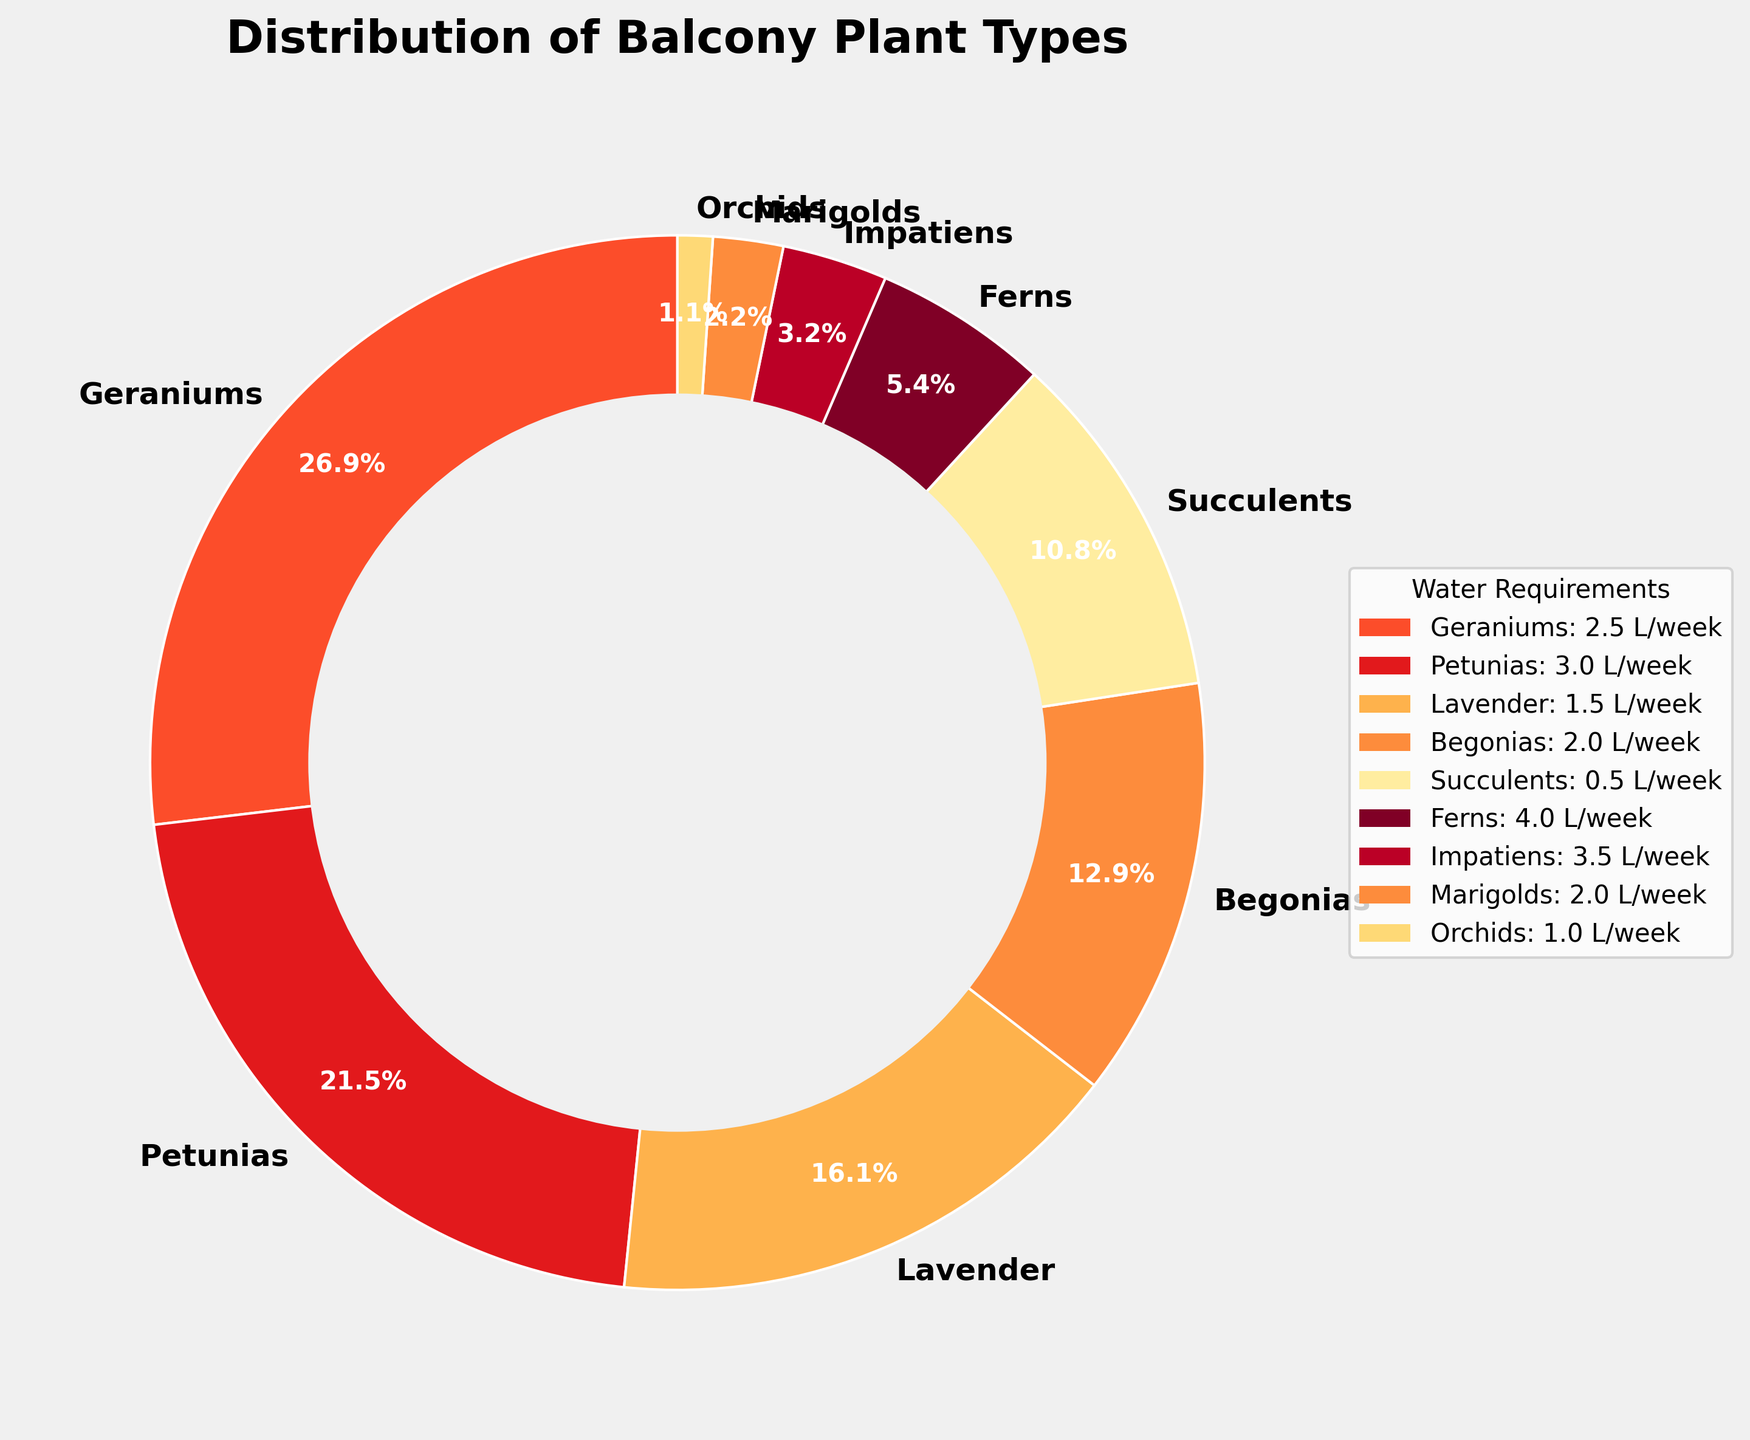what type of plant occupies the largest portion of the pie chart? By looking at the distribution of the plant types in the pie chart, the largest portion can be identified. Geraniums have the largest segment, occupying 25% of the chart.
Answer: Geraniums Which plant requires the most water per week? The legend in the pie chart lists the water requirements for each plant. Ferns require the most water, at 4 L/week.
Answer: Ferns Which plant types require less than 3 L/week of water? By examining the legend and looking for plants with water requirements less than 3 L/week, we see that Geraniums, Lavender, Begonias, Succulents, Marigolds, and Orchids fit this category.
Answer: Geraniums, Lavender, Begonias, Succulents, Marigolds, Orchids What percentage of tenants have plants that require 2 L/week of water? By looking at the pie chart for the plant type Begonias and its corresponding percentage, we find that Begonias, which require 2 L/week of water, occupy 12% of the pie chart.
Answer: 12% How much water per week do the top three most popular plants combined require? Calculate the sum of the water requirements for the three most popular plants: Geraniums (2.5 L/week), Petunias (3 L/week), and Lavender (1.5 L/week). 2.5 + 3 + 1.5 = 7
Answer: 7 L/week What is the visual difference between the plant with the least percentage and the plant with the highest percentage? By comparing the size of the wedges in the pie chart, Geraniums and Orchids can be identified as the largest and smallest segments respectively, with significantly larger wedge sizes for Geraniums.
Answer: Geraniums have a much larger wedge than Orchids Which plants have a water requirement greater than 3 L/week, and what are their percentages? By checking the legend for water requirements over 3 L/week, we find Ferns (5%) and Impatiens (3%) meet the criteria.
Answer: Ferns (5%), Impatiens (3%) What is the combined percentage of plants that require exactly 3 L/week of water? Look for plants with 3 L/week water requirements in the legend. Petunias (20%) and Impatiens (3%) meet this, so the combined total is 20 + 3 = 23%.
Answer: 23% What visual feature indicates the water requirement differences between plant types? The color gradient in the pie chart, ranging from lighter to darker shades, corresponds to the different water requirements of the plant types.
Answer: Color gradient Compare the water requirements for Ferns and Succulents. From the legend, Ferns require 4 L/week and Succulents require 0.5 L/week. The difference is 4 - 0.5 = 3.5 L/week.
Answer: 3.5 L/week 